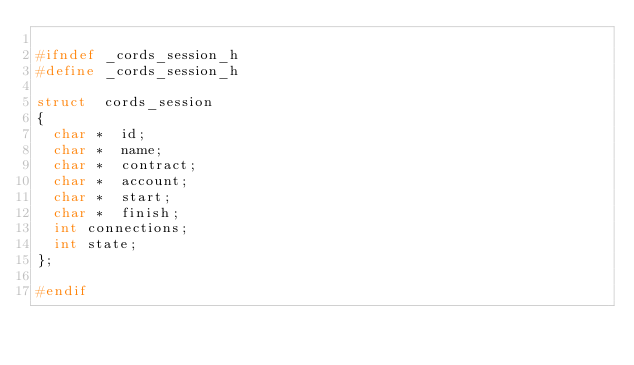<code> <loc_0><loc_0><loc_500><loc_500><_C_>
#ifndef	_cords_session_h
#define	_cords_session_h

struct	cords_session
{
	char *	id;
	char *	name;
	char *	contract;
	char *	account;
	char *	start;
	char *	finish;
	int	connections;
	int	state;
};

#endif





</code> 